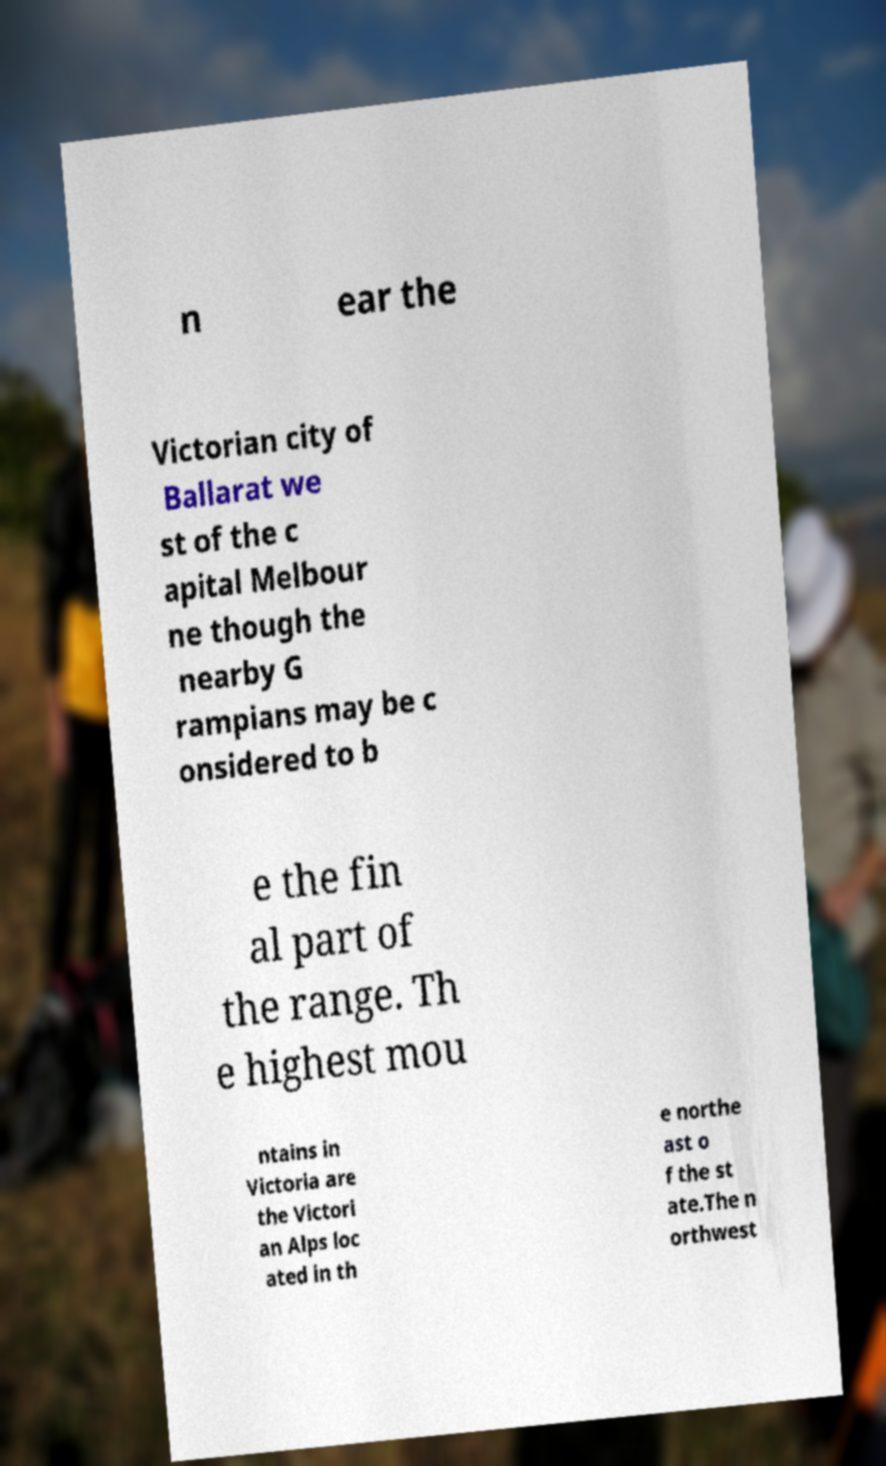Could you assist in decoding the text presented in this image and type it out clearly? n ear the Victorian city of Ballarat we st of the c apital Melbour ne though the nearby G rampians may be c onsidered to b e the fin al part of the range. Th e highest mou ntains in Victoria are the Victori an Alps loc ated in th e northe ast o f the st ate.The n orthwest 